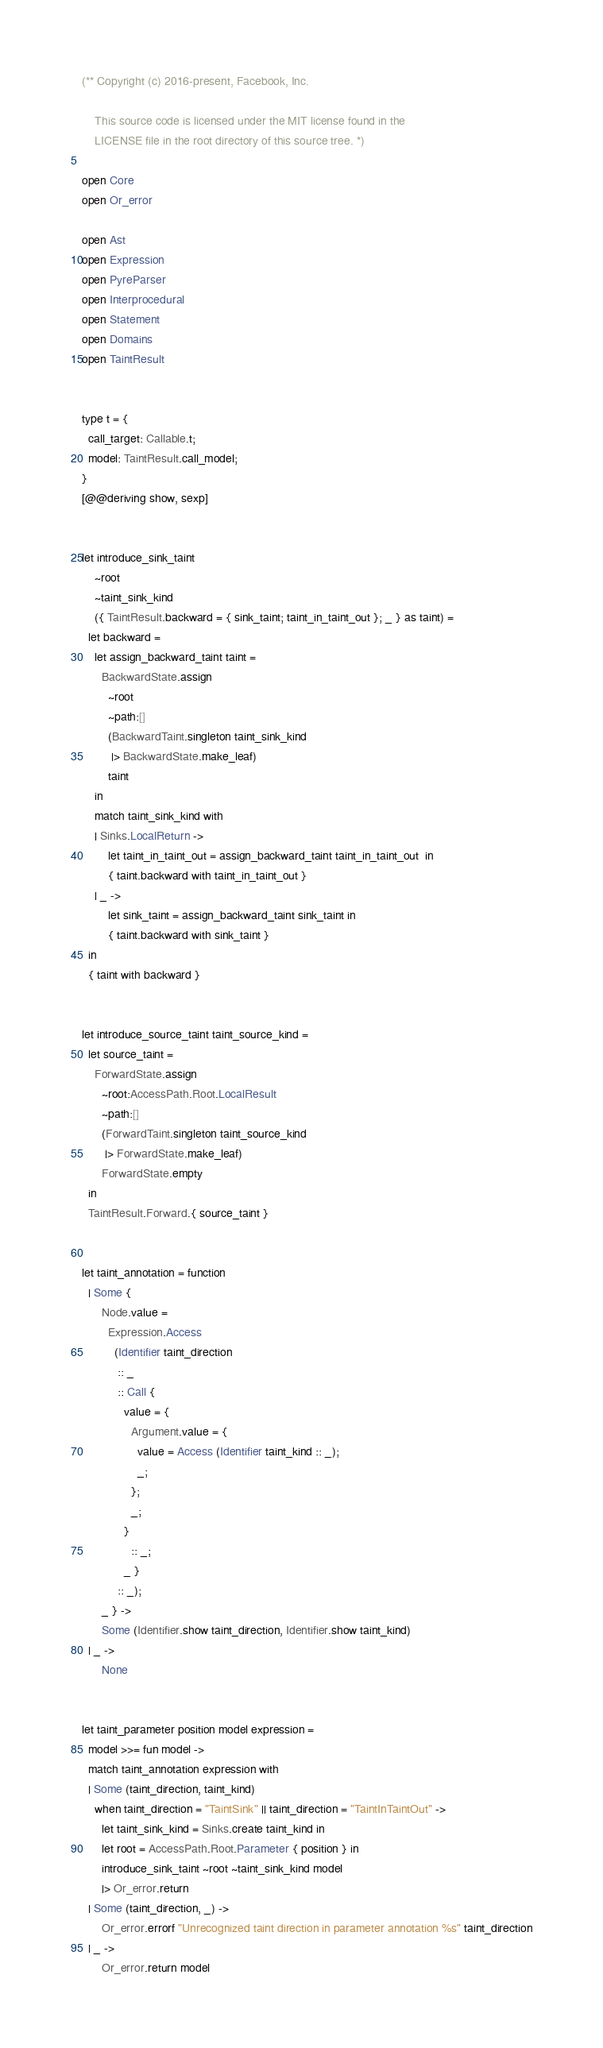<code> <loc_0><loc_0><loc_500><loc_500><_OCaml_>(** Copyright (c) 2016-present, Facebook, Inc.

    This source code is licensed under the MIT license found in the
    LICENSE file in the root directory of this source tree. *)

open Core
open Or_error

open Ast
open Expression
open PyreParser
open Interprocedural
open Statement
open Domains
open TaintResult


type t = {
  call_target: Callable.t;
  model: TaintResult.call_model;
}
[@@deriving show, sexp]


let introduce_sink_taint
    ~root
    ~taint_sink_kind
    ({ TaintResult.backward = { sink_taint; taint_in_taint_out }; _ } as taint) =
  let backward =
    let assign_backward_taint taint =
      BackwardState.assign
        ~root
        ~path:[]
        (BackwardTaint.singleton taint_sink_kind
         |> BackwardState.make_leaf)
        taint
    in
    match taint_sink_kind with
    | Sinks.LocalReturn ->
        let taint_in_taint_out = assign_backward_taint taint_in_taint_out  in
        { taint.backward with taint_in_taint_out }
    | _ ->
        let sink_taint = assign_backward_taint sink_taint in
        { taint.backward with sink_taint }
  in
  { taint with backward }


let introduce_source_taint taint_source_kind =
  let source_taint =
    ForwardState.assign
      ~root:AccessPath.Root.LocalResult
      ~path:[]
      (ForwardTaint.singleton taint_source_kind
       |> ForwardState.make_leaf)
      ForwardState.empty
  in
  TaintResult.Forward.{ source_taint }


let taint_annotation = function
  | Some {
      Node.value =
        Expression.Access
          (Identifier taint_direction
           :: _
           :: Call {
             value = {
               Argument.value = {
                 value = Access (Identifier taint_kind :: _);
                 _;
               };
               _;
             }
               :: _;
             _ }
           :: _);
      _ } ->
      Some (Identifier.show taint_direction, Identifier.show taint_kind)
  | _ ->
      None


let taint_parameter position model expression =
  model >>= fun model ->
  match taint_annotation expression with
  | Some (taint_direction, taint_kind)
    when taint_direction = "TaintSink" || taint_direction = "TaintInTaintOut" ->
      let taint_sink_kind = Sinks.create taint_kind in
      let root = AccessPath.Root.Parameter { position } in
      introduce_sink_taint ~root ~taint_sink_kind model
      |> Or_error.return
  | Some (taint_direction, _) ->
      Or_error.errorf "Unrecognized taint direction in parameter annotation %s" taint_direction
  | _ ->
      Or_error.return model

</code> 